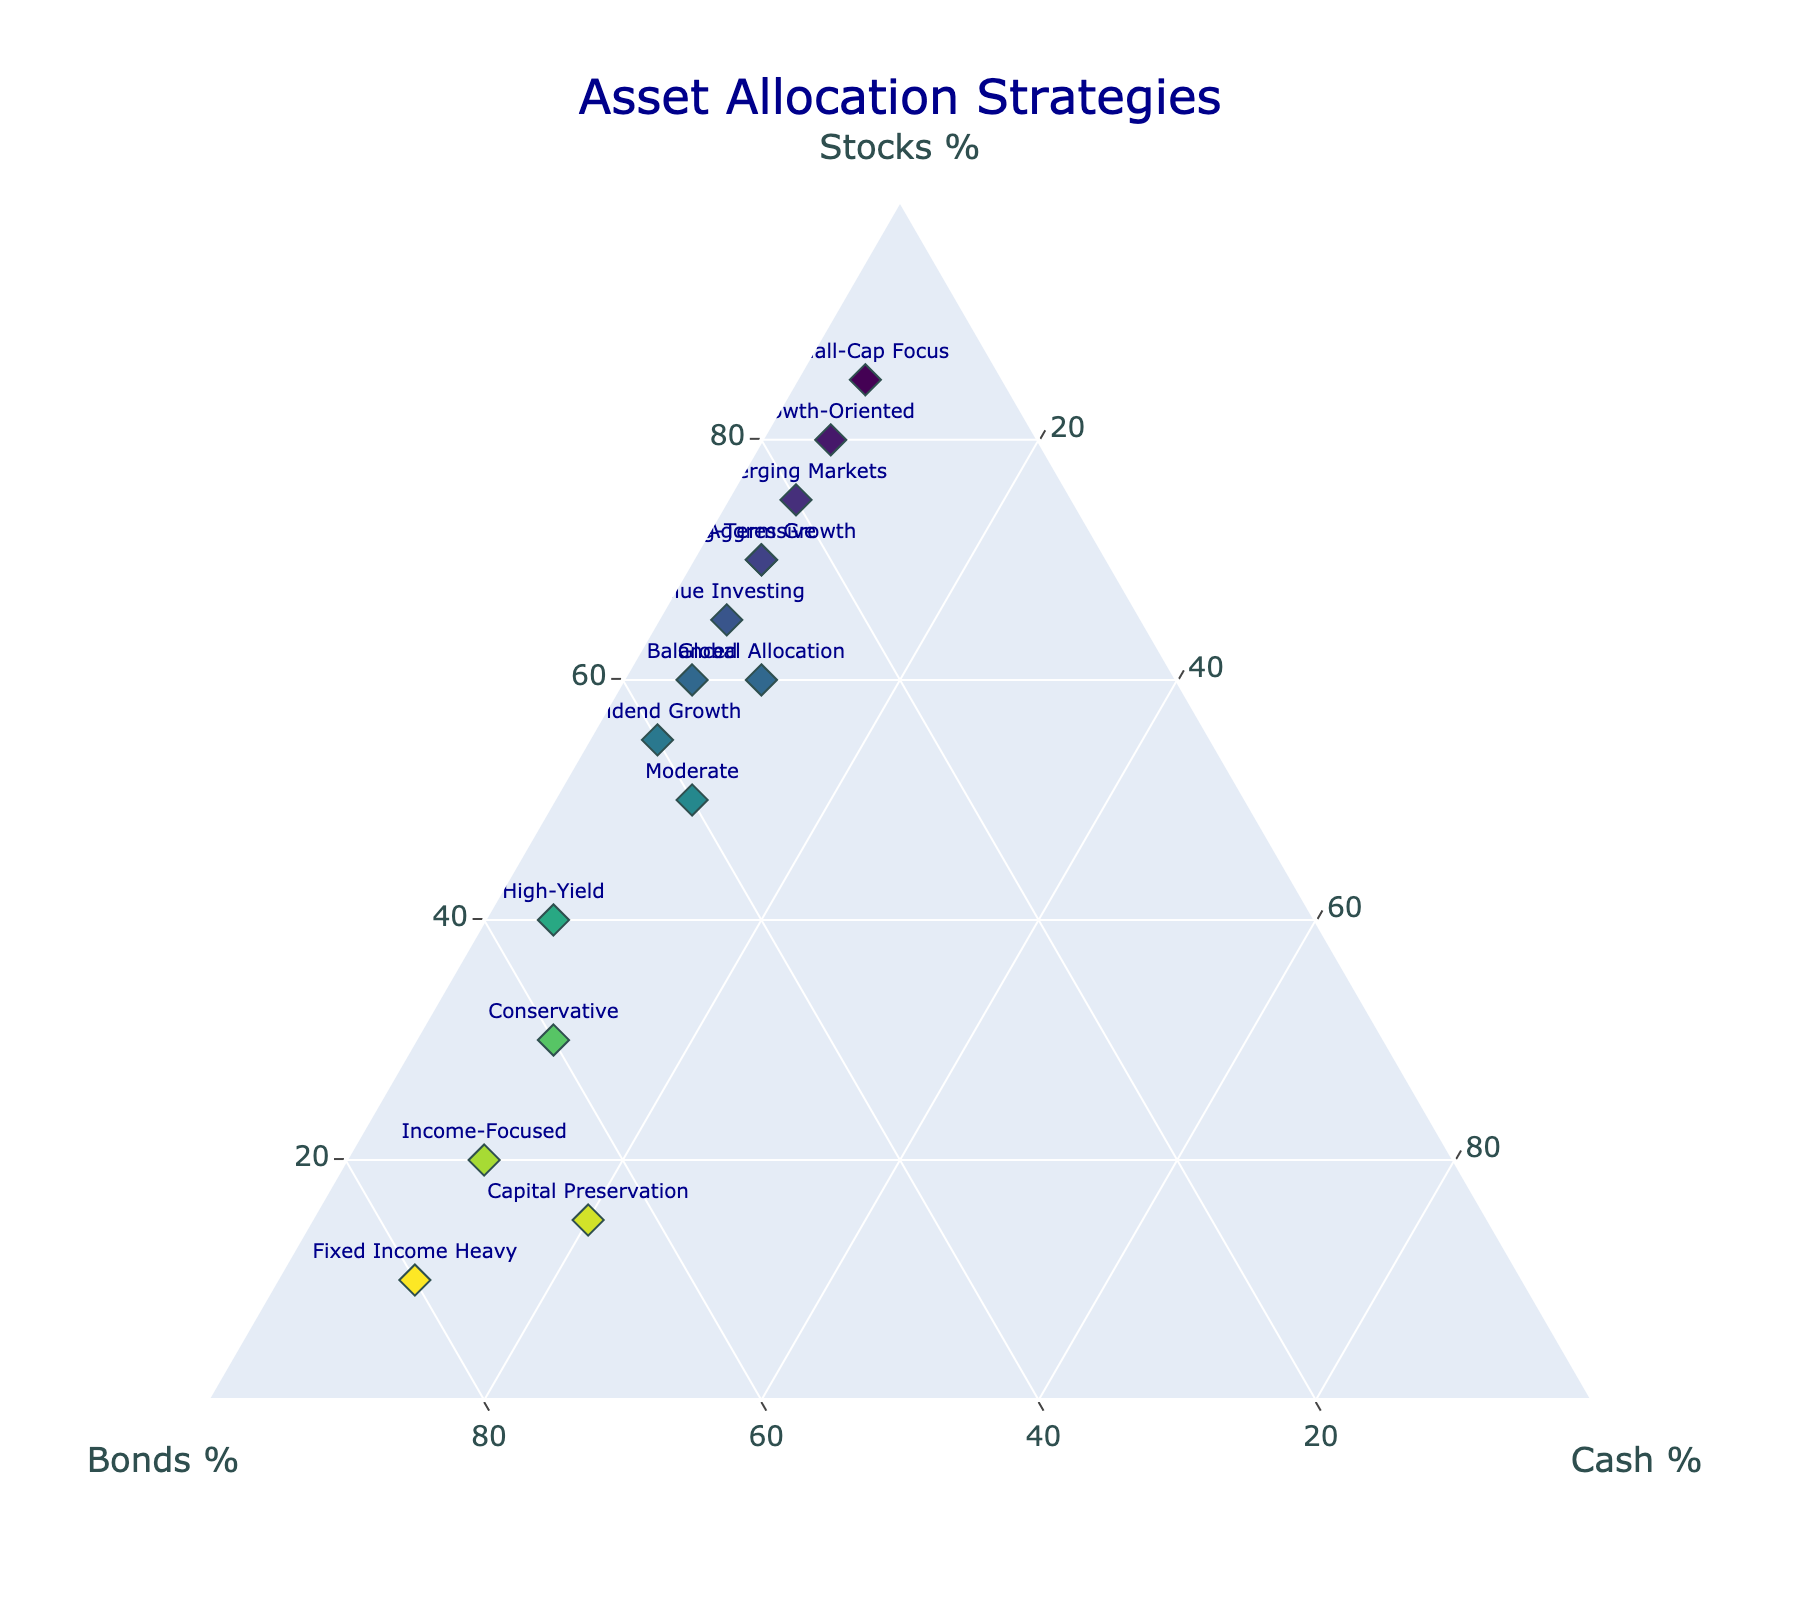which asset allocation strategy has the highest percentage of stocks? The Growth-Oriented strategy has the highest percentage of stocks, at 80%. This is clearly seen as it's placed at the outer boundary of the ternary plot where the Stocks percentage is highest.
Answer: Growth-Oriented how many strategies have exactly 10% cash allocation? Six strategies have exactly 10% cash: Conservative, Moderate, Income-Focused, Global Allocation, Fixed Income Heavy, and Long-Term Growth. Each is represented with a 'text' label on the ternary plot at exactly 10% on the Cash axis.
Answer: Six what is the balance of stocks, bonds, and cash for the aggressive strategy? The Aggressive strategy is balanced with 70% stocks, 25% bonds, and 5% cash. This is found by locating the 'Aggressive' label on the plot and reading the corresponding values for stocks, bonds, and cash.
Answer: 70% stocks, 25% bonds, 5% cash which strategy has equal percentage allocation for bonds and cash? No strategy has an equal percentage allocation for bonds and cash. The bond and cash percentages for all strategies differ as observed from their labels on the plot.
Answer: None which strategy is closer to the cash apex compared to others? The Fixed Income Heavy and Capital Preservation strategies are the closest to the cash apex. The Fixed Income Heavy, in particular, has the highest cash allocation at 20%.
Answer: Fixed Income Heavy compare the bond allocations of conservative and dividend growth strategies. The Conservative strategy has a bond allocation of 60%, while the Dividend Growth strategy has a bond allocation of 40%. This difference is visible by comparing the positions of their labels along the Bonds axis on the ternary plot.
Answer: Conservative has 60% bonds, Dividend Growth has 40% bonds which strategy is more diversified between stocks, bonds, and cash? The Moderate strategy appears more diversified with 50% stocks, 40% bonds, and 10% cash, giving a relatively balanced allocation across all three components compared to other strategies on the plot.
Answer: Moderate choose a strategy that has at least 70% allocation in bonds. The Income-Focused and Fixed Income Heavy strategies both meet the criterion with bond allocations of 70% and 80%, respectively.
Answer: Income-Focused, Fixed Income Heavy 